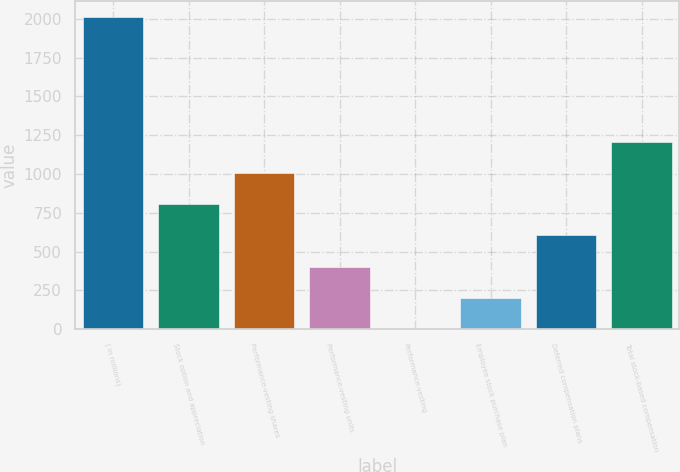Convert chart. <chart><loc_0><loc_0><loc_500><loc_500><bar_chart><fcel>( in millions)<fcel>Stock option and appreciation<fcel>Performance-vesting shares<fcel>Performance-vesting units<fcel>Performance-vesting<fcel>Employee stock purchase plan<fcel>Deferred compensation plans<fcel>Total stock-based compensation<nl><fcel>2012<fcel>804.86<fcel>1006.05<fcel>402.48<fcel>0.1<fcel>201.29<fcel>603.67<fcel>1207.24<nl></chart> 